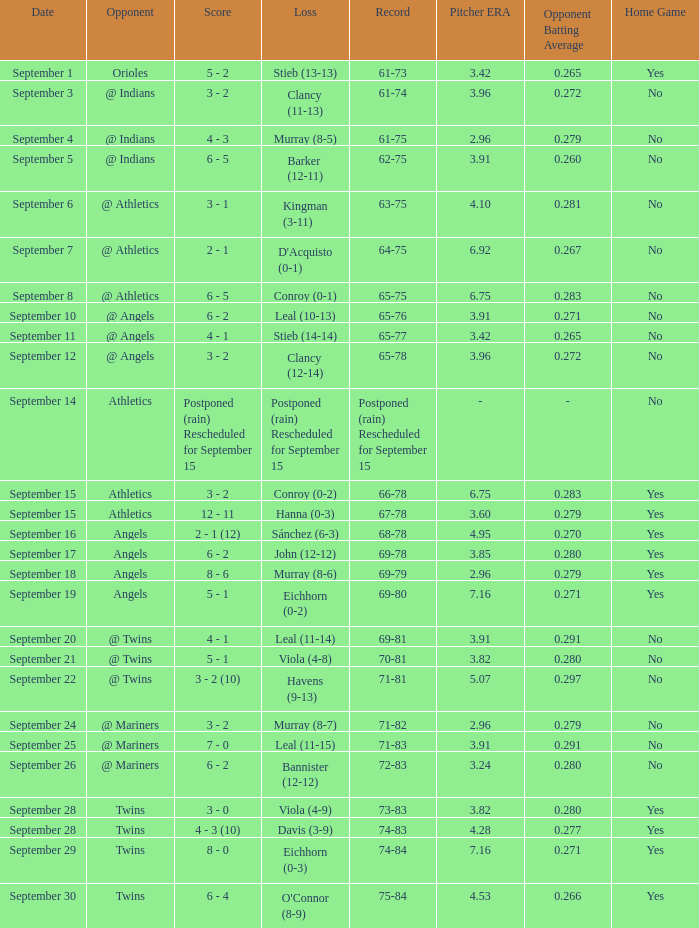Name the loss for record of 71-81 Havens (9-13). 